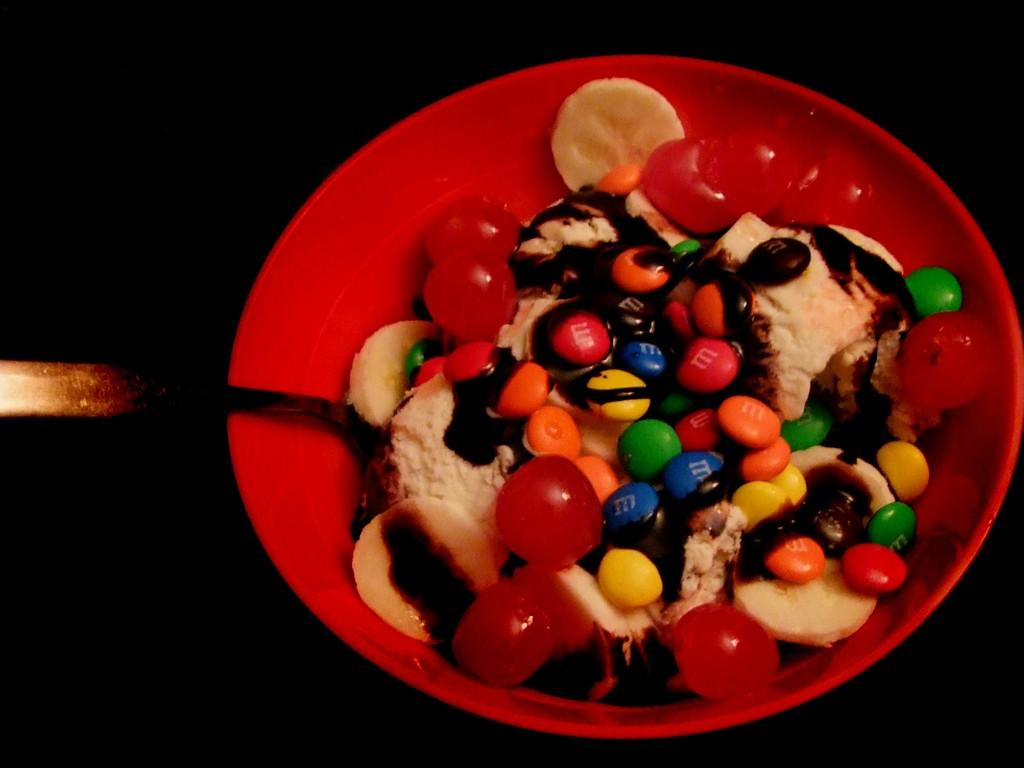What is in the bowl that is visible in the image? There are food items in a bowl in the image. What utensil is visible in the image? There is a spoon visible in the image. What can be said about the background of the image? The background of the image is dark. What type of cheese is being cast at the feast in the image? There is no cheese or feast present in the image. 